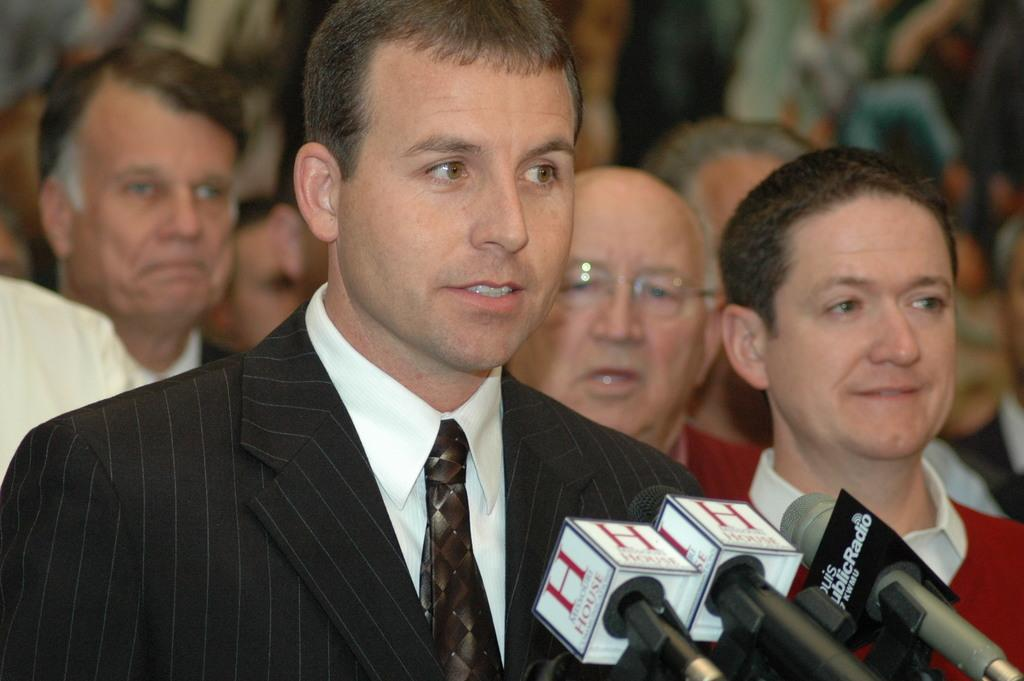What is the main subject of the image? There is a person in the image. What is the person wearing on their upper body? The person is wearing a white shirt and a black coat. What type of accessory is the person wearing around their neck? The person is wearing a tie. What animals are present in the image? There are mice in front of the person. Can you describe the background of the image? There are people standing in the background of the image. What type of pie is being thrown at the person in the image? There is no pie present in the image; it only features a person, mice, and people in the background. 